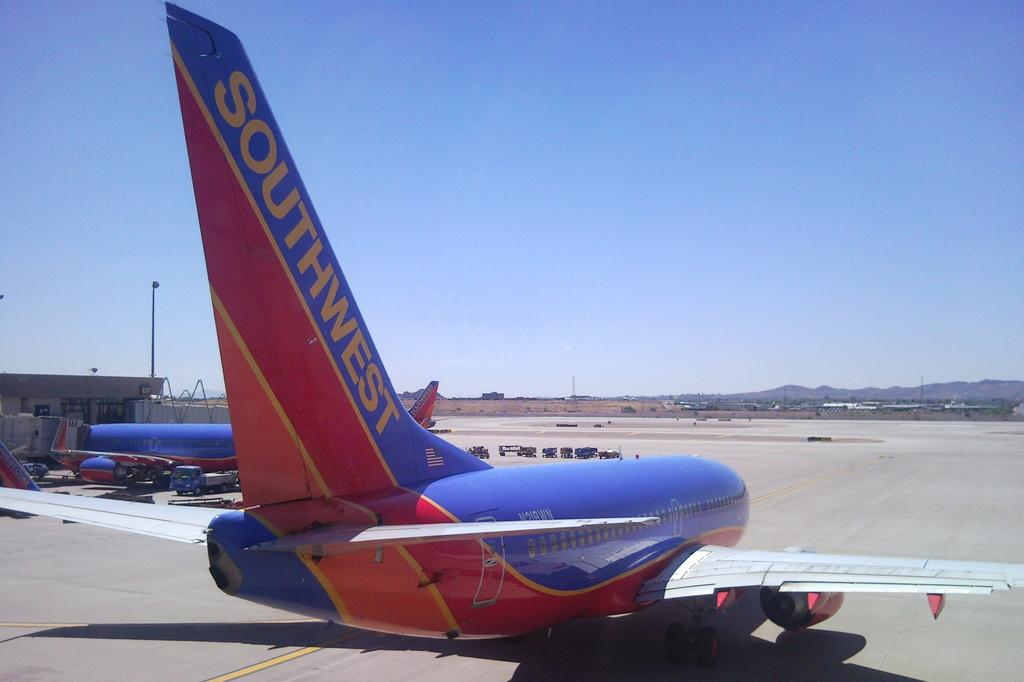<image>
Relay a brief, clear account of the picture shown. A red and blue Southwest Airlines passgenger plane. 